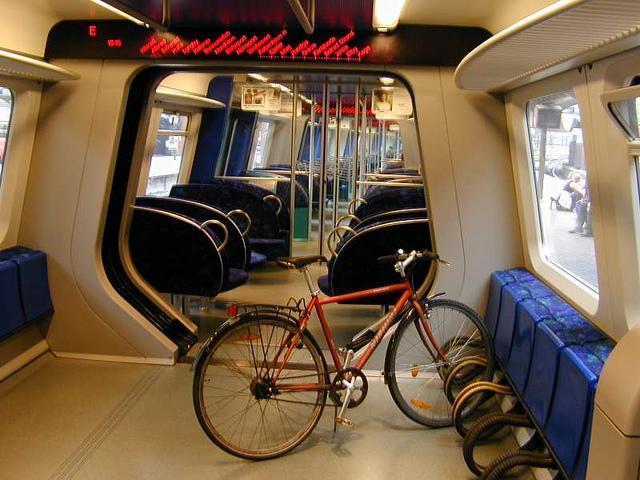How many chairs are there?
Give a very brief answer. 5. 